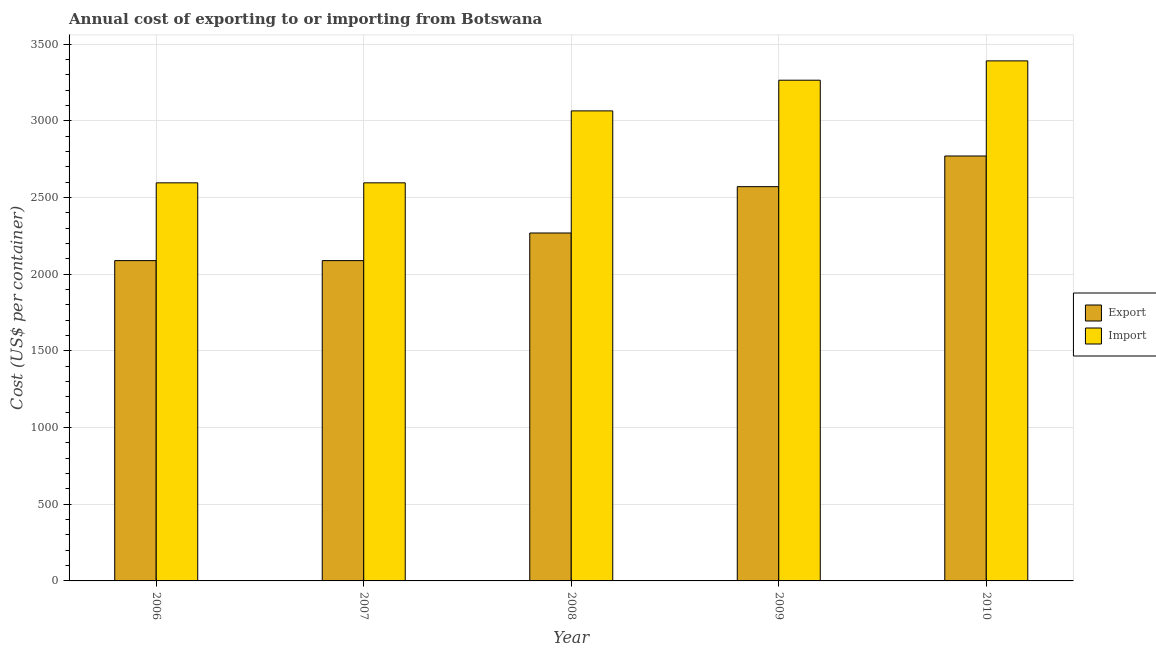How many different coloured bars are there?
Provide a short and direct response. 2. How many groups of bars are there?
Give a very brief answer. 5. How many bars are there on the 2nd tick from the left?
Your answer should be very brief. 2. How many bars are there on the 5th tick from the right?
Offer a very short reply. 2. In how many cases, is the number of bars for a given year not equal to the number of legend labels?
Offer a very short reply. 0. What is the export cost in 2008?
Your answer should be compact. 2268. Across all years, what is the maximum import cost?
Keep it short and to the point. 3390. Across all years, what is the minimum import cost?
Give a very brief answer. 2595. What is the total export cost in the graph?
Provide a succinct answer. 1.18e+04. What is the difference between the export cost in 2009 and that in 2010?
Provide a succinct answer. -200. What is the difference between the export cost in 2008 and the import cost in 2010?
Offer a terse response. -502. What is the average export cost per year?
Offer a very short reply. 2356.8. What is the ratio of the import cost in 2007 to that in 2009?
Keep it short and to the point. 0.8. Is the import cost in 2006 less than that in 2007?
Provide a short and direct response. No. What is the difference between the highest and the second highest import cost?
Your response must be concise. 126. What is the difference between the highest and the lowest import cost?
Offer a very short reply. 795. In how many years, is the import cost greater than the average import cost taken over all years?
Offer a terse response. 3. Is the sum of the export cost in 2006 and 2010 greater than the maximum import cost across all years?
Provide a short and direct response. Yes. What does the 2nd bar from the left in 2006 represents?
Provide a short and direct response. Import. What does the 1st bar from the right in 2007 represents?
Ensure brevity in your answer.  Import. Are all the bars in the graph horizontal?
Your answer should be compact. No. How many years are there in the graph?
Keep it short and to the point. 5. What is the difference between two consecutive major ticks on the Y-axis?
Your answer should be very brief. 500. Does the graph contain grids?
Ensure brevity in your answer.  Yes. How many legend labels are there?
Provide a succinct answer. 2. How are the legend labels stacked?
Provide a succinct answer. Vertical. What is the title of the graph?
Make the answer very short. Annual cost of exporting to or importing from Botswana. Does "Private funds" appear as one of the legend labels in the graph?
Ensure brevity in your answer.  No. What is the label or title of the X-axis?
Keep it short and to the point. Year. What is the label or title of the Y-axis?
Your answer should be compact. Cost (US$ per container). What is the Cost (US$ per container) of Export in 2006?
Give a very brief answer. 2088. What is the Cost (US$ per container) in Import in 2006?
Provide a succinct answer. 2595. What is the Cost (US$ per container) in Export in 2007?
Give a very brief answer. 2088. What is the Cost (US$ per container) of Import in 2007?
Your answer should be compact. 2595. What is the Cost (US$ per container) of Export in 2008?
Keep it short and to the point. 2268. What is the Cost (US$ per container) of Import in 2008?
Offer a terse response. 3064. What is the Cost (US$ per container) of Export in 2009?
Your answer should be very brief. 2570. What is the Cost (US$ per container) in Import in 2009?
Ensure brevity in your answer.  3264. What is the Cost (US$ per container) in Export in 2010?
Your answer should be compact. 2770. What is the Cost (US$ per container) in Import in 2010?
Offer a very short reply. 3390. Across all years, what is the maximum Cost (US$ per container) of Export?
Provide a short and direct response. 2770. Across all years, what is the maximum Cost (US$ per container) in Import?
Your response must be concise. 3390. Across all years, what is the minimum Cost (US$ per container) in Export?
Give a very brief answer. 2088. Across all years, what is the minimum Cost (US$ per container) of Import?
Ensure brevity in your answer.  2595. What is the total Cost (US$ per container) of Export in the graph?
Your answer should be compact. 1.18e+04. What is the total Cost (US$ per container) in Import in the graph?
Provide a short and direct response. 1.49e+04. What is the difference between the Cost (US$ per container) of Import in 2006 and that in 2007?
Provide a succinct answer. 0. What is the difference between the Cost (US$ per container) of Export in 2006 and that in 2008?
Your answer should be very brief. -180. What is the difference between the Cost (US$ per container) of Import in 2006 and that in 2008?
Your response must be concise. -469. What is the difference between the Cost (US$ per container) of Export in 2006 and that in 2009?
Keep it short and to the point. -482. What is the difference between the Cost (US$ per container) of Import in 2006 and that in 2009?
Your answer should be compact. -669. What is the difference between the Cost (US$ per container) of Export in 2006 and that in 2010?
Ensure brevity in your answer.  -682. What is the difference between the Cost (US$ per container) in Import in 2006 and that in 2010?
Provide a succinct answer. -795. What is the difference between the Cost (US$ per container) in Export in 2007 and that in 2008?
Your response must be concise. -180. What is the difference between the Cost (US$ per container) of Import in 2007 and that in 2008?
Provide a short and direct response. -469. What is the difference between the Cost (US$ per container) of Export in 2007 and that in 2009?
Provide a succinct answer. -482. What is the difference between the Cost (US$ per container) in Import in 2007 and that in 2009?
Your response must be concise. -669. What is the difference between the Cost (US$ per container) in Export in 2007 and that in 2010?
Offer a terse response. -682. What is the difference between the Cost (US$ per container) in Import in 2007 and that in 2010?
Provide a short and direct response. -795. What is the difference between the Cost (US$ per container) of Export in 2008 and that in 2009?
Your answer should be very brief. -302. What is the difference between the Cost (US$ per container) of Import in 2008 and that in 2009?
Your response must be concise. -200. What is the difference between the Cost (US$ per container) of Export in 2008 and that in 2010?
Your answer should be compact. -502. What is the difference between the Cost (US$ per container) in Import in 2008 and that in 2010?
Ensure brevity in your answer.  -326. What is the difference between the Cost (US$ per container) in Export in 2009 and that in 2010?
Offer a terse response. -200. What is the difference between the Cost (US$ per container) in Import in 2009 and that in 2010?
Your answer should be compact. -126. What is the difference between the Cost (US$ per container) of Export in 2006 and the Cost (US$ per container) of Import in 2007?
Your answer should be very brief. -507. What is the difference between the Cost (US$ per container) in Export in 2006 and the Cost (US$ per container) in Import in 2008?
Your response must be concise. -976. What is the difference between the Cost (US$ per container) in Export in 2006 and the Cost (US$ per container) in Import in 2009?
Your answer should be compact. -1176. What is the difference between the Cost (US$ per container) of Export in 2006 and the Cost (US$ per container) of Import in 2010?
Make the answer very short. -1302. What is the difference between the Cost (US$ per container) in Export in 2007 and the Cost (US$ per container) in Import in 2008?
Ensure brevity in your answer.  -976. What is the difference between the Cost (US$ per container) in Export in 2007 and the Cost (US$ per container) in Import in 2009?
Provide a succinct answer. -1176. What is the difference between the Cost (US$ per container) of Export in 2007 and the Cost (US$ per container) of Import in 2010?
Ensure brevity in your answer.  -1302. What is the difference between the Cost (US$ per container) of Export in 2008 and the Cost (US$ per container) of Import in 2009?
Make the answer very short. -996. What is the difference between the Cost (US$ per container) in Export in 2008 and the Cost (US$ per container) in Import in 2010?
Make the answer very short. -1122. What is the difference between the Cost (US$ per container) of Export in 2009 and the Cost (US$ per container) of Import in 2010?
Ensure brevity in your answer.  -820. What is the average Cost (US$ per container) in Export per year?
Your answer should be compact. 2356.8. What is the average Cost (US$ per container) in Import per year?
Provide a succinct answer. 2981.6. In the year 2006, what is the difference between the Cost (US$ per container) in Export and Cost (US$ per container) in Import?
Make the answer very short. -507. In the year 2007, what is the difference between the Cost (US$ per container) in Export and Cost (US$ per container) in Import?
Keep it short and to the point. -507. In the year 2008, what is the difference between the Cost (US$ per container) of Export and Cost (US$ per container) of Import?
Give a very brief answer. -796. In the year 2009, what is the difference between the Cost (US$ per container) of Export and Cost (US$ per container) of Import?
Make the answer very short. -694. In the year 2010, what is the difference between the Cost (US$ per container) of Export and Cost (US$ per container) of Import?
Offer a terse response. -620. What is the ratio of the Cost (US$ per container) in Export in 2006 to that in 2007?
Give a very brief answer. 1. What is the ratio of the Cost (US$ per container) of Export in 2006 to that in 2008?
Your response must be concise. 0.92. What is the ratio of the Cost (US$ per container) in Import in 2006 to that in 2008?
Offer a terse response. 0.85. What is the ratio of the Cost (US$ per container) in Export in 2006 to that in 2009?
Provide a succinct answer. 0.81. What is the ratio of the Cost (US$ per container) in Import in 2006 to that in 2009?
Your response must be concise. 0.8. What is the ratio of the Cost (US$ per container) in Export in 2006 to that in 2010?
Your answer should be very brief. 0.75. What is the ratio of the Cost (US$ per container) of Import in 2006 to that in 2010?
Offer a very short reply. 0.77. What is the ratio of the Cost (US$ per container) in Export in 2007 to that in 2008?
Offer a terse response. 0.92. What is the ratio of the Cost (US$ per container) in Import in 2007 to that in 2008?
Give a very brief answer. 0.85. What is the ratio of the Cost (US$ per container) in Export in 2007 to that in 2009?
Your answer should be very brief. 0.81. What is the ratio of the Cost (US$ per container) of Import in 2007 to that in 2009?
Offer a very short reply. 0.8. What is the ratio of the Cost (US$ per container) in Export in 2007 to that in 2010?
Offer a very short reply. 0.75. What is the ratio of the Cost (US$ per container) of Import in 2007 to that in 2010?
Provide a succinct answer. 0.77. What is the ratio of the Cost (US$ per container) of Export in 2008 to that in 2009?
Your answer should be compact. 0.88. What is the ratio of the Cost (US$ per container) in Import in 2008 to that in 2009?
Offer a terse response. 0.94. What is the ratio of the Cost (US$ per container) in Export in 2008 to that in 2010?
Provide a succinct answer. 0.82. What is the ratio of the Cost (US$ per container) in Import in 2008 to that in 2010?
Your answer should be very brief. 0.9. What is the ratio of the Cost (US$ per container) in Export in 2009 to that in 2010?
Keep it short and to the point. 0.93. What is the ratio of the Cost (US$ per container) in Import in 2009 to that in 2010?
Offer a terse response. 0.96. What is the difference between the highest and the second highest Cost (US$ per container) in Import?
Your answer should be very brief. 126. What is the difference between the highest and the lowest Cost (US$ per container) of Export?
Offer a very short reply. 682. What is the difference between the highest and the lowest Cost (US$ per container) in Import?
Your answer should be compact. 795. 